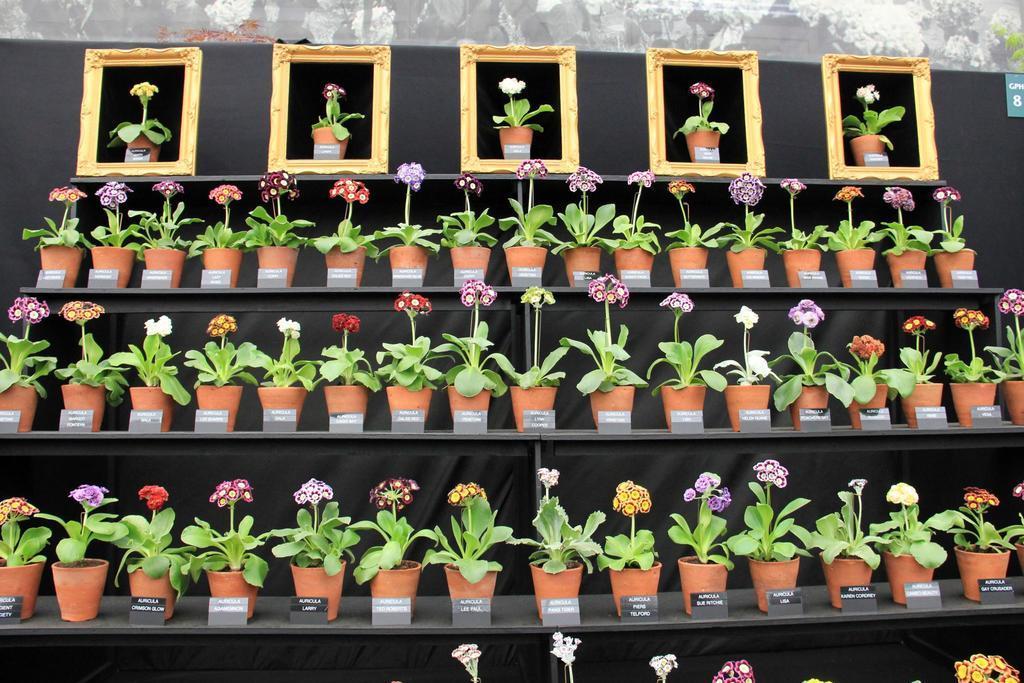Please provide a concise description of this image. In this image, we can see a shelf, on the shelf, we can see a flower pot with plants and flowers with different colors, we can also see the board on the flower pot, on which some text some text is written on it. In the background, we can see black color, gray color and white color. At the bottom, we can see some flowers. 